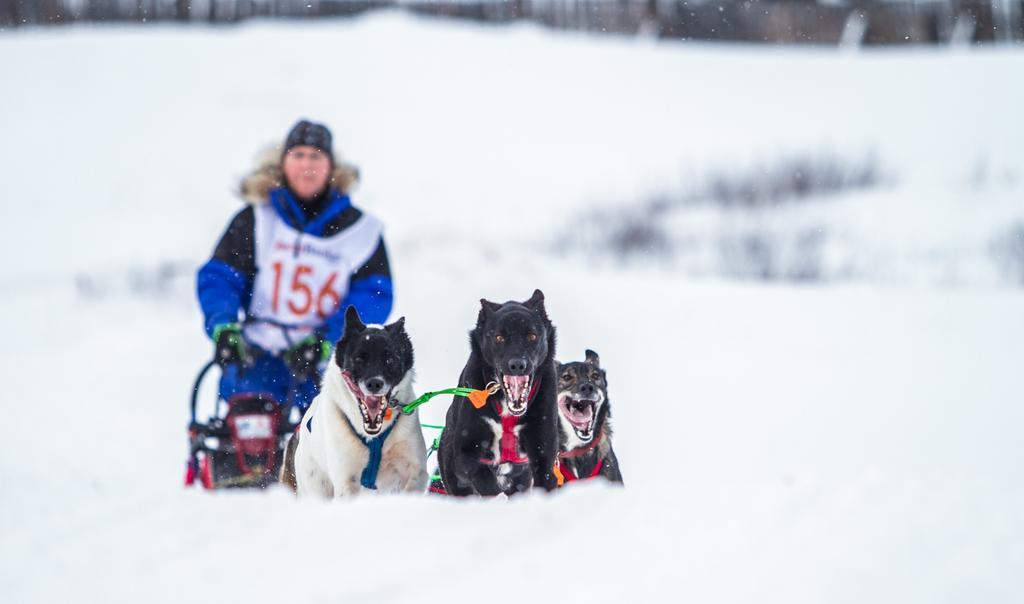Describe this image in one or two sentences. In this image there is a person standing on the surface of the snow, in front of the person there are three dogs. 